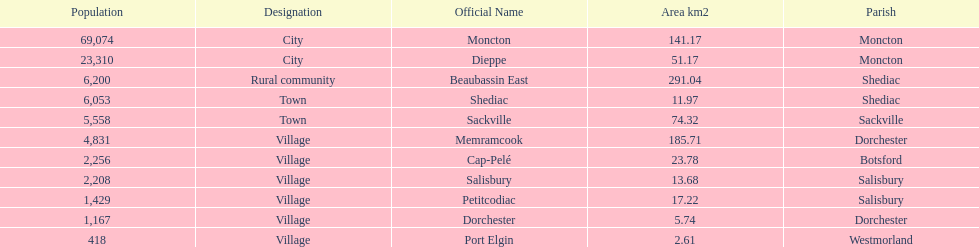How many municipalities have areas that are below 50 square kilometers? 6. 